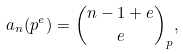<formula> <loc_0><loc_0><loc_500><loc_500>a _ { n } ( p ^ { e } ) = \binom { n - 1 + e } { e } _ { p } ,</formula> 